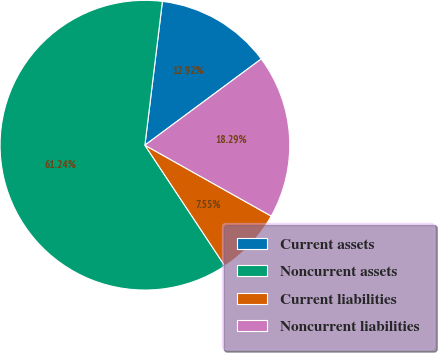Convert chart to OTSL. <chart><loc_0><loc_0><loc_500><loc_500><pie_chart><fcel>Current assets<fcel>Noncurrent assets<fcel>Current liabilities<fcel>Noncurrent liabilities<nl><fcel>12.92%<fcel>61.23%<fcel>7.55%<fcel>18.29%<nl></chart> 